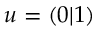Convert formula to latex. <formula><loc_0><loc_0><loc_500><loc_500>u = \left ( 0 | 1 \right )</formula> 